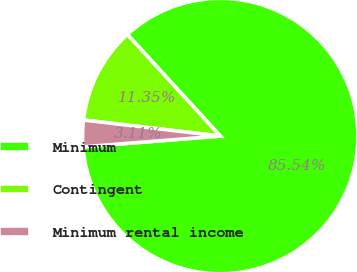Convert chart to OTSL. <chart><loc_0><loc_0><loc_500><loc_500><pie_chart><fcel>Minimum<fcel>Contingent<fcel>Minimum rental income<nl><fcel>85.54%<fcel>11.35%<fcel>3.11%<nl></chart> 